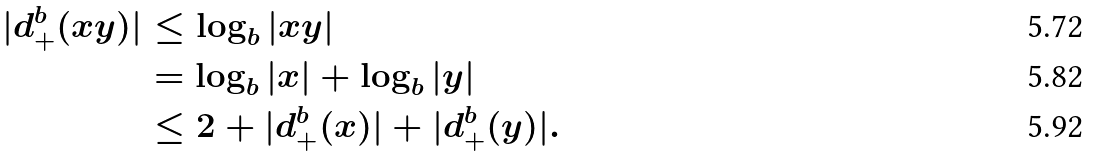<formula> <loc_0><loc_0><loc_500><loc_500>| d _ { + } ^ { b } ( x y ) | & \leq \log _ { b } | x y | \\ & = \log _ { b } | x | + \log _ { b } | y | \\ & \leq 2 + | d _ { + } ^ { b } ( x ) | + | d _ { + } ^ { b } ( y ) | .</formula> 